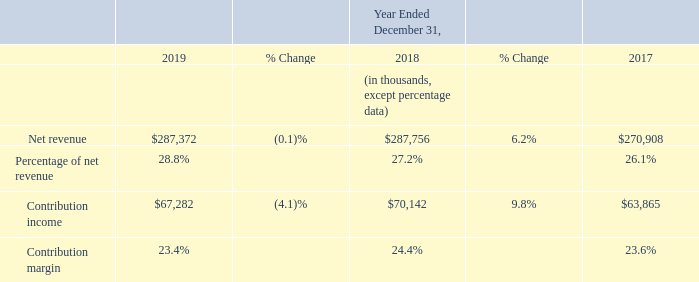2019 vs 2018
SMB segment net revenue was flat for the year ended December 31, 2019 compared to the prior year, primarily due to a decline in net revenue of our
network storage products, substantially offset by growth in net revenue of our switch products. Geographically, net revenue grew in APAC, but declined in Americas and EMEA.
Contribution income decreased for the year ended December 31, 2019 compared to the prior year, primarily as a result of lower gross margin attainment, partially offset by lower operating expenses as a proportion of net revenue. Contribution margin decreased for the year ended December 31, 2019 compared to the prior year, primarily lower gross margin attainment mainly resulting from foreign exchange headwinds due to the strengthening of the U.S. dollar as well as higher provisions for sales returns.
2018 vs 2017
SMB segment net revenue increased for the year ended December 31, 2018 compared to the prior year, primarily due to growth in switches, partially offset by the decrease in network storage. SMB experienced growth in net revenue across all regions. SMB net revenue was further benefited by lower provisions for sales returns deemed to be a reduction of net revenue.
Contribution income increased for the year ended December 31, 2018 compared to the prior year, primarily due to increasing net revenue and improved gross margin performance not being met with proportionate increases in operating expense compared to the prior period.
What accounts for the decrease in contribution income in 2019? Lower gross margin attainment, partially offset by lower operating expenses as a proportion of net revenue. What accounts for the increase in net revenue in 2018? Due to growth in switches, partially offset by the decrease in network storage. Which regions did the net revenue decline in 2019? Americas and emea. What was the percentage change in net revenue from 2017 to 2019?
Answer scale should be: percent. (287,372-270,908)/270,908 
Answer: 6.08. In which year is the contribution margin the highest? 24.4% > 23.6% > 23.4%
Answer: 2018. What was the change in contribution income from 2017 to 2018?
Answer scale should be: thousand. $70,142 - $63,865 
Answer: 6277. 